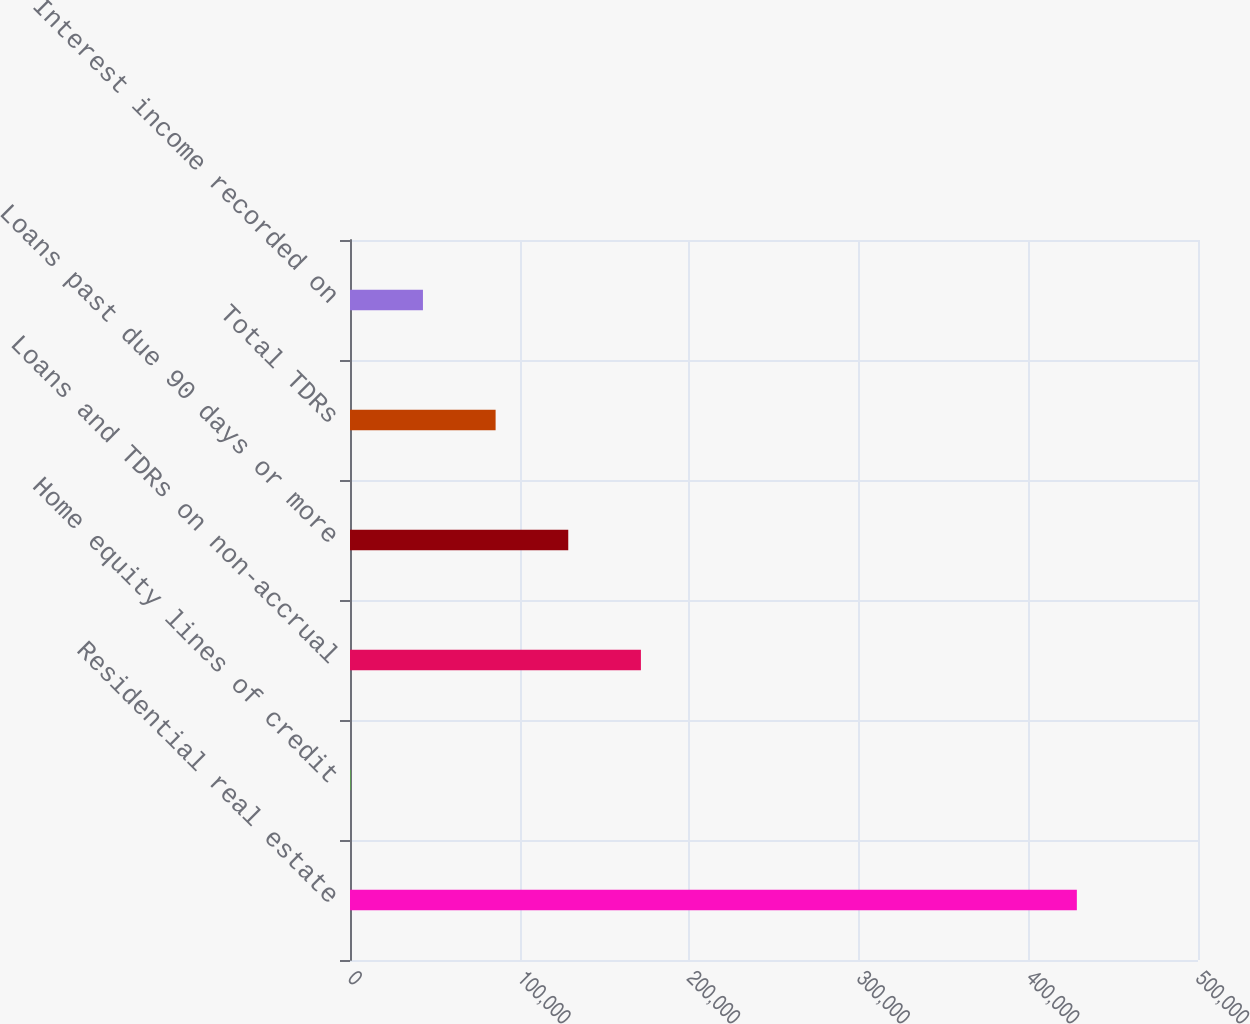Convert chart to OTSL. <chart><loc_0><loc_0><loc_500><loc_500><bar_chart><fcel>Residential real estate<fcel>Home equity lines of credit<fcel>Loans and TDRs on non-accrual<fcel>Loans past due 90 days or more<fcel>Total TDRs<fcel>Interest income recorded on<nl><fcel>428568<fcel>174<fcel>171532<fcel>128692<fcel>85852.8<fcel>43013.4<nl></chart> 